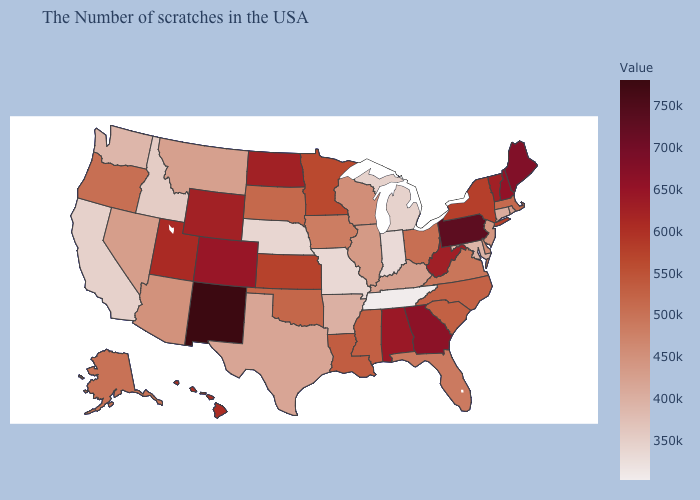Does Arkansas have a lower value than Maine?
Quick response, please. Yes. Which states have the highest value in the USA?
Give a very brief answer. New Mexico. Among the states that border North Carolina , which have the lowest value?
Be succinct. Tennessee. Which states have the lowest value in the USA?
Answer briefly. Tennessee. 